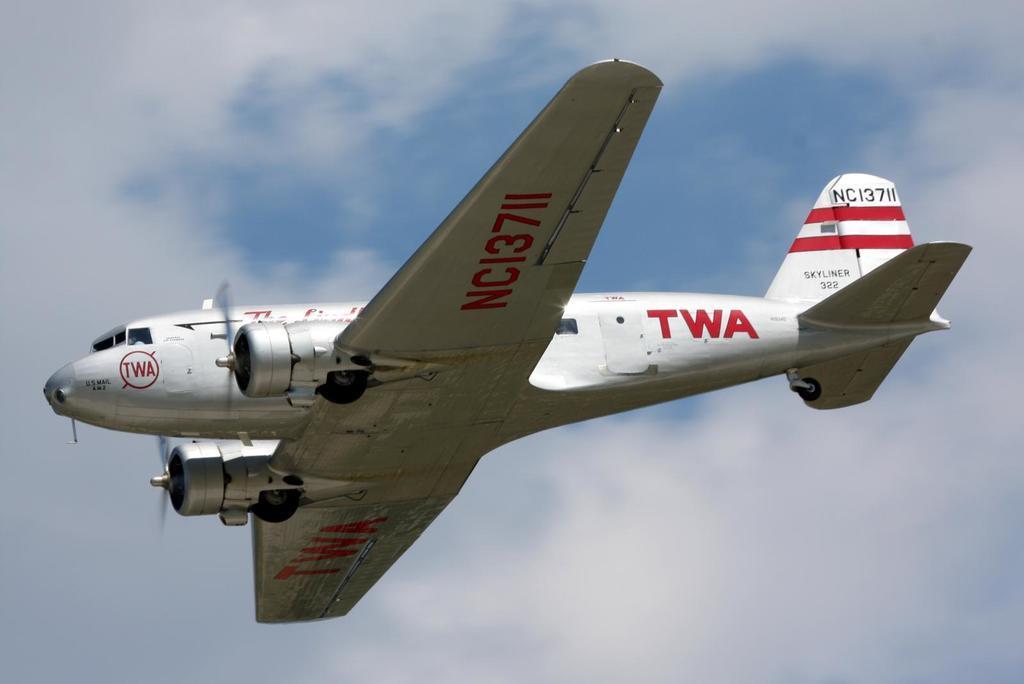Could you give a brief overview of what you see in this image? In this picture we can observe an airplane flying in the air which is in silver color. We can observe red color text on the airplane. In the background there is a sky with some clouds. 